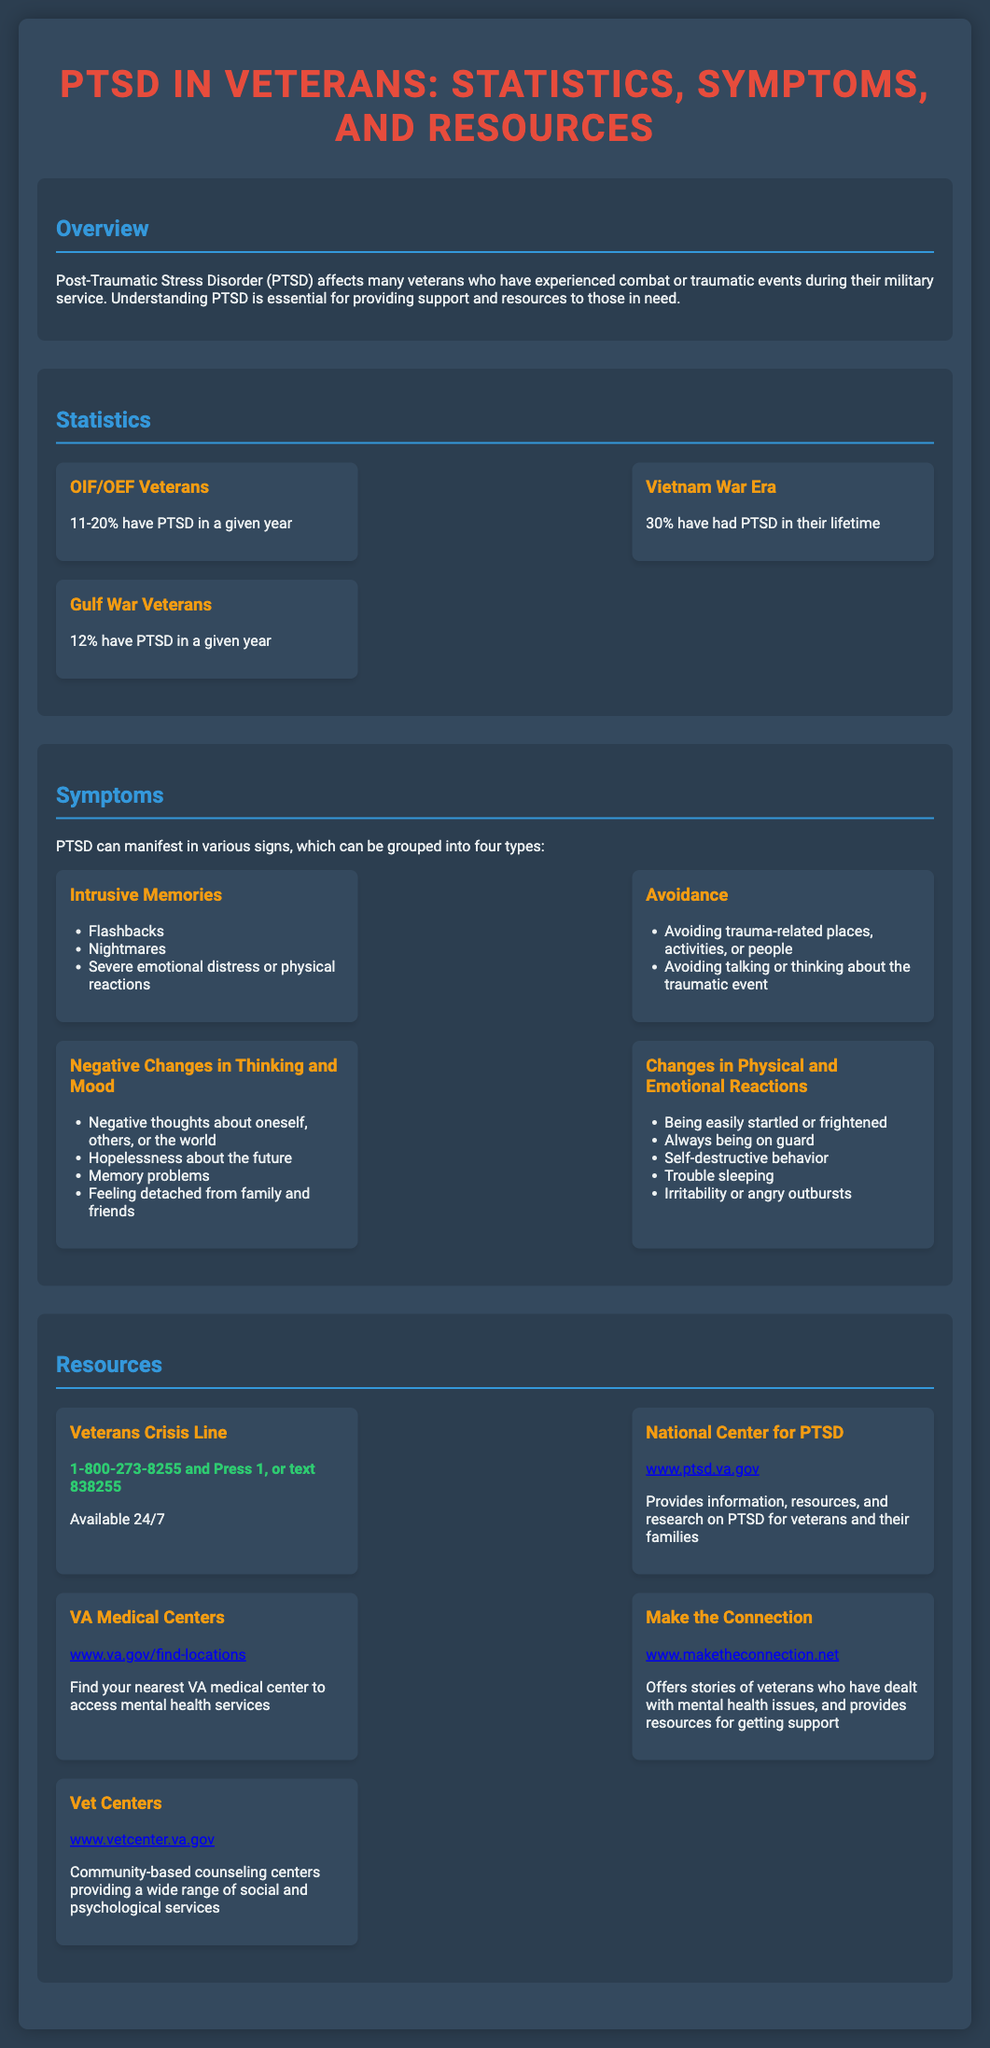what percentage of OIF/OEF veterans have PTSD in a given year? The document states that 11-20% of OIF/OEF veterans have PTSD in a given year.
Answer: 11-20% what is the lifetime PTSD rate for Vietnam War veterans? According to the document, 30% of Vietnam War veterans have had PTSD in their lifetime.
Answer: 30% what are the four types of PTSD symptoms listed? The document mentions Intrusive Memories, Avoidance, Negative Changes in Thinking and Mood, and Changes in Physical and Emotional Reactions as the four types of symptoms.
Answer: Intrusive Memories, Avoidance, Negative Changes in Thinking and Mood, Changes in Physical and Emotional Reactions which resource provides information and research on PTSD? The document indicates that the National Center for PTSD provides information, resources, and research on PTSD for veterans and their families.
Answer: National Center for PTSD what is the contact number for the Veterans Crisis Line? The document lists the contact number as 1-800-273-8255 and Press 1.
Answer: 1-800-273-8255 and Press 1 how can one access mental health services at VA Medical Centers? The document suggests visiting the website www.va.gov/find-locations to find the nearest VA medical center for mental health services.
Answer: www.va.gov/find-locations what symptom involves flashbacks and nightmares? The document categorizes these as part of Intrusive Memories, which is a type of PTSD symptom.
Answer: Intrusive Memories how many percent of Gulf War veterans have PTSD in a given year? The document states that 12% of Gulf War veterans have PTSD in a given year.
Answer: 12% 